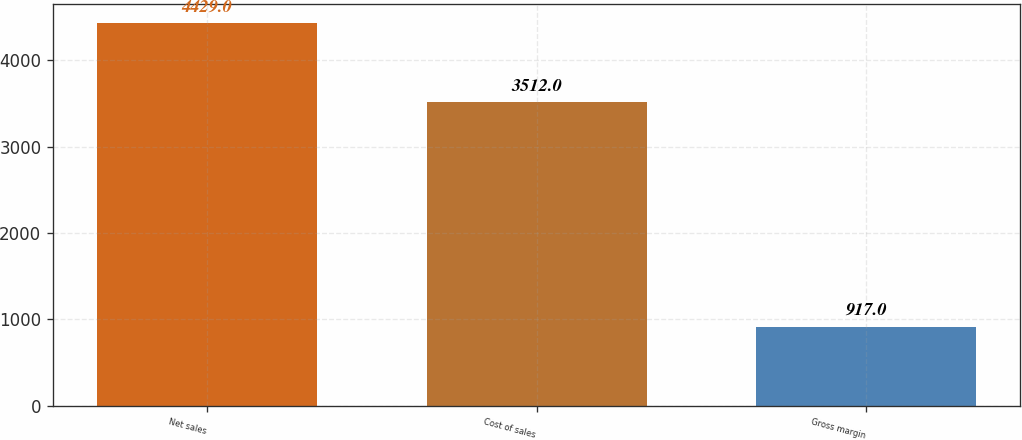<chart> <loc_0><loc_0><loc_500><loc_500><bar_chart><fcel>Net sales<fcel>Cost of sales<fcel>Gross margin<nl><fcel>4429<fcel>3512<fcel>917<nl></chart> 